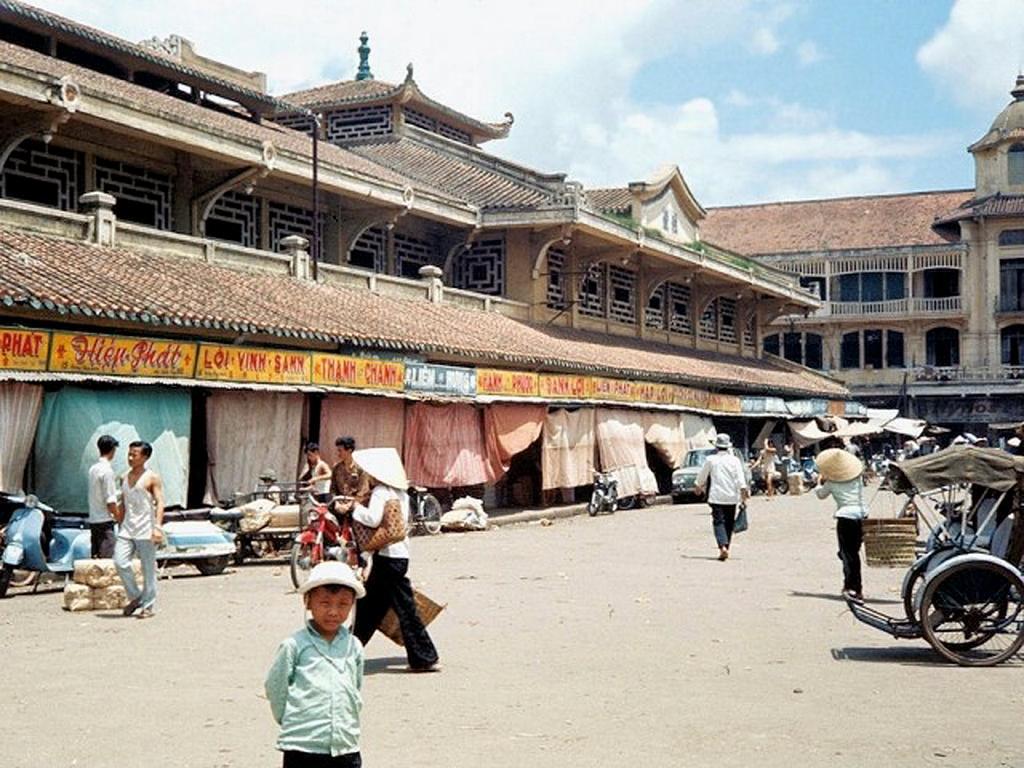Could you give a brief overview of what you see in this image? In this picture I can see buildings and few people walking and I can see a car, motorcycle, bicycle and few scooters parked and I can see boards with some text and few clothes hanging and I can see few people are wearing caps on their heads and a cart on the right side of the picture and a blue cloudy sky. 